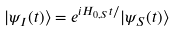<formula> <loc_0><loc_0><loc_500><loc_500>| \psi _ { I } ( t ) \rangle = e ^ { i H _ { 0 , S } t / } | \psi _ { S } ( t ) \rangle</formula> 